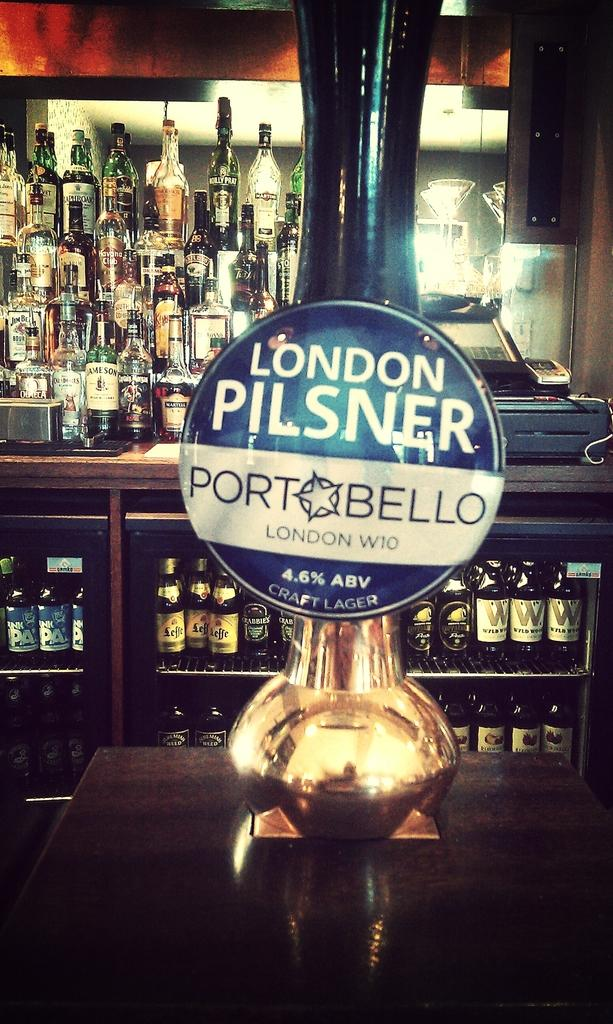<image>
Summarize the visual content of the image. A keg tap for London Pilsner which contains 4.6% ABV 